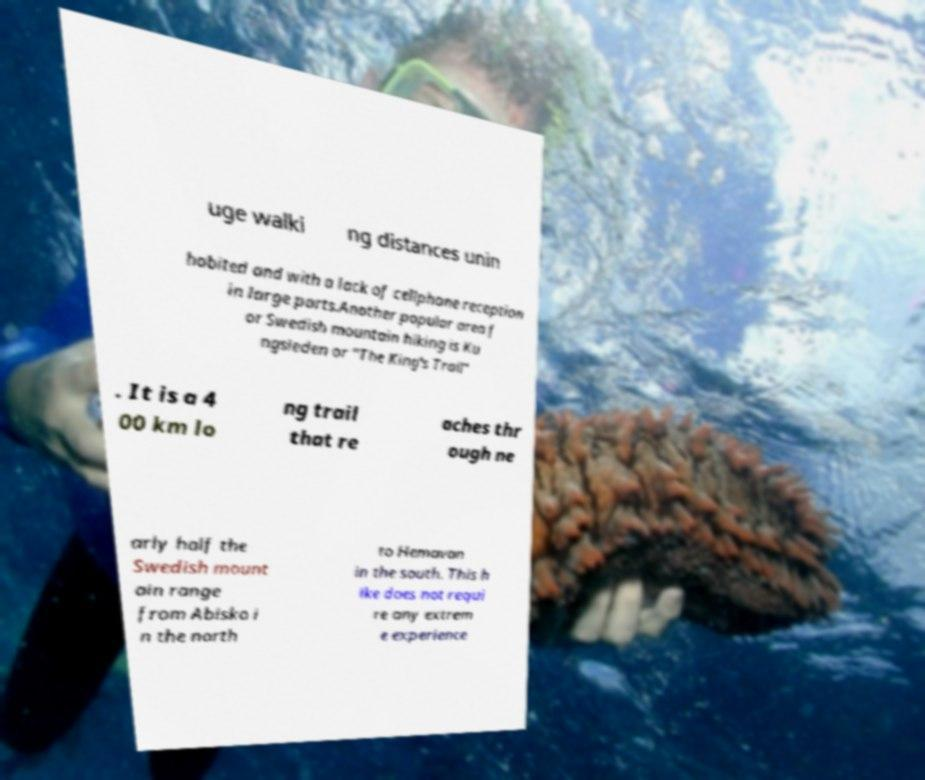Can you accurately transcribe the text from the provided image for me? uge walki ng distances unin habited and with a lack of cellphone reception in large parts.Another popular area f or Swedish mountain hiking is Ku ngsleden or "The King's Trail" . It is a 4 00 km lo ng trail that re aches thr ough ne arly half the Swedish mount ain range from Abisko i n the north to Hemavan in the south. This h ike does not requi re any extrem e experience 